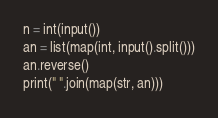<code> <loc_0><loc_0><loc_500><loc_500><_Python_>n = int(input())
an = list(map(int, input().split()))
an.reverse()
print(" ".join(map(str, an)))
</code> 